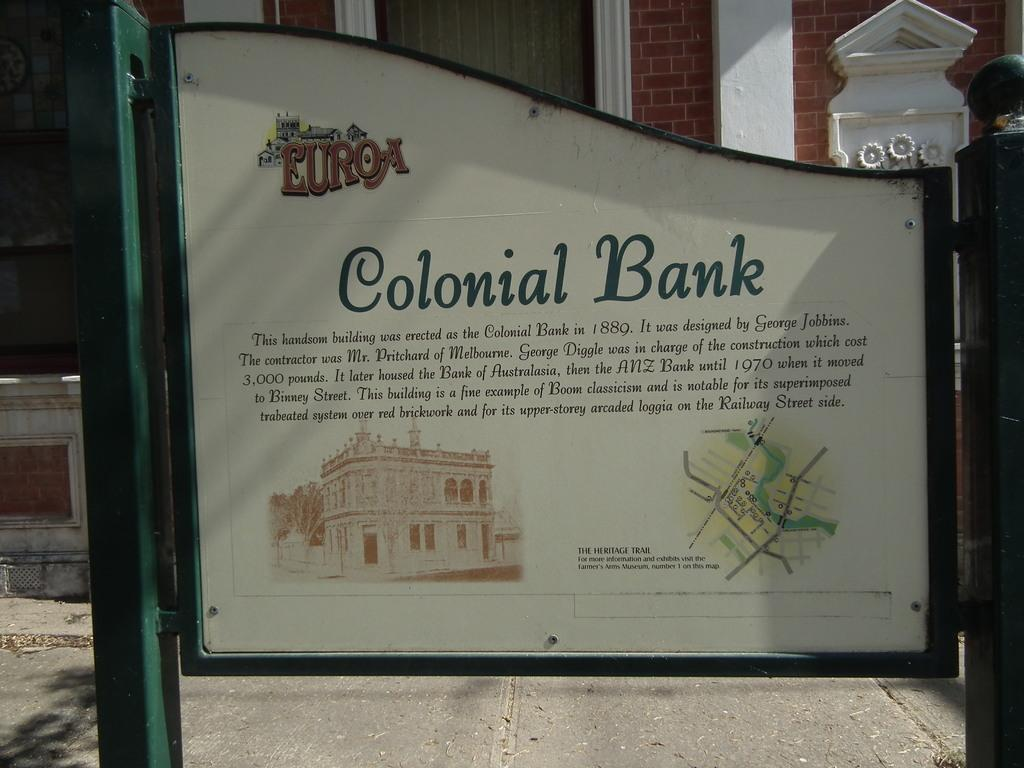<image>
Present a compact description of the photo's key features. A sign for the Colonial Bank including a drawing of the building and a map. 